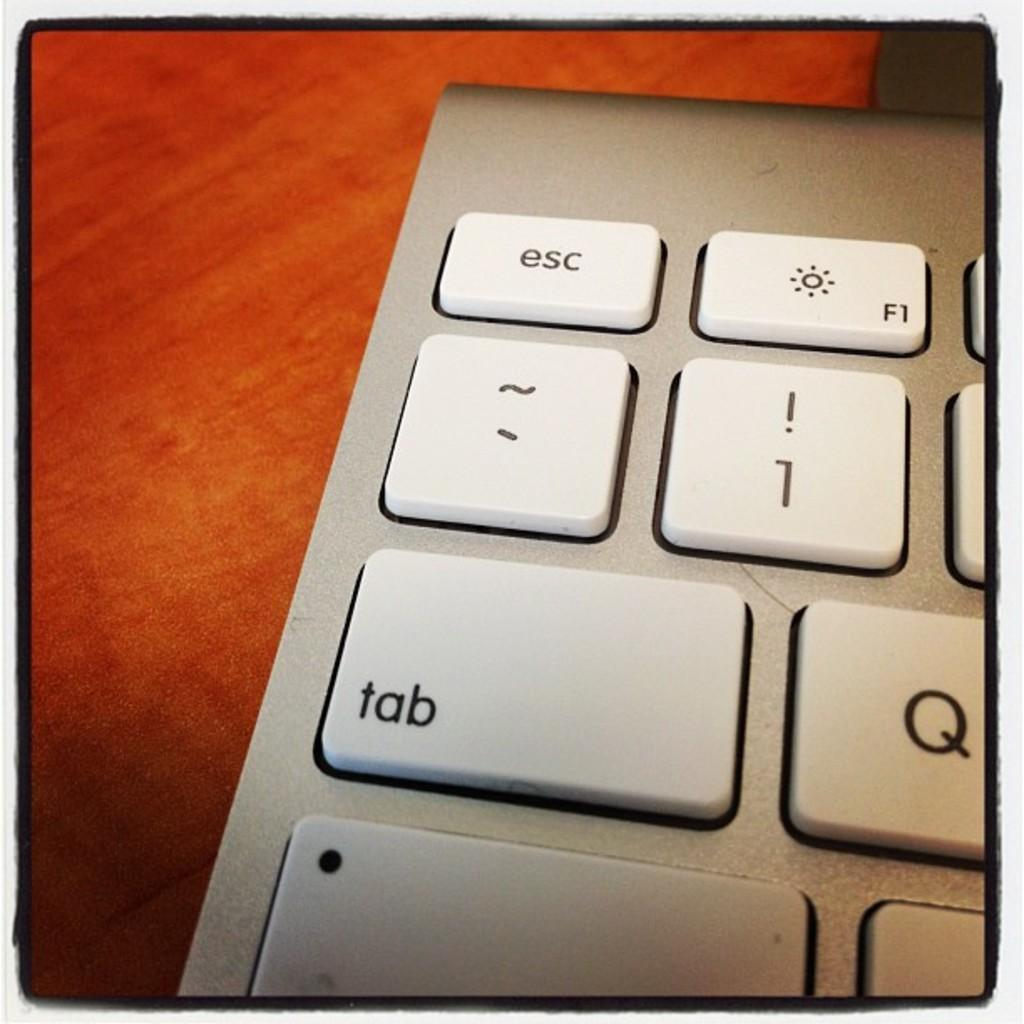<image>
Offer a succinct explanation of the picture presented. The one key on the laptop keyboard has an exclamation point on the same key. 